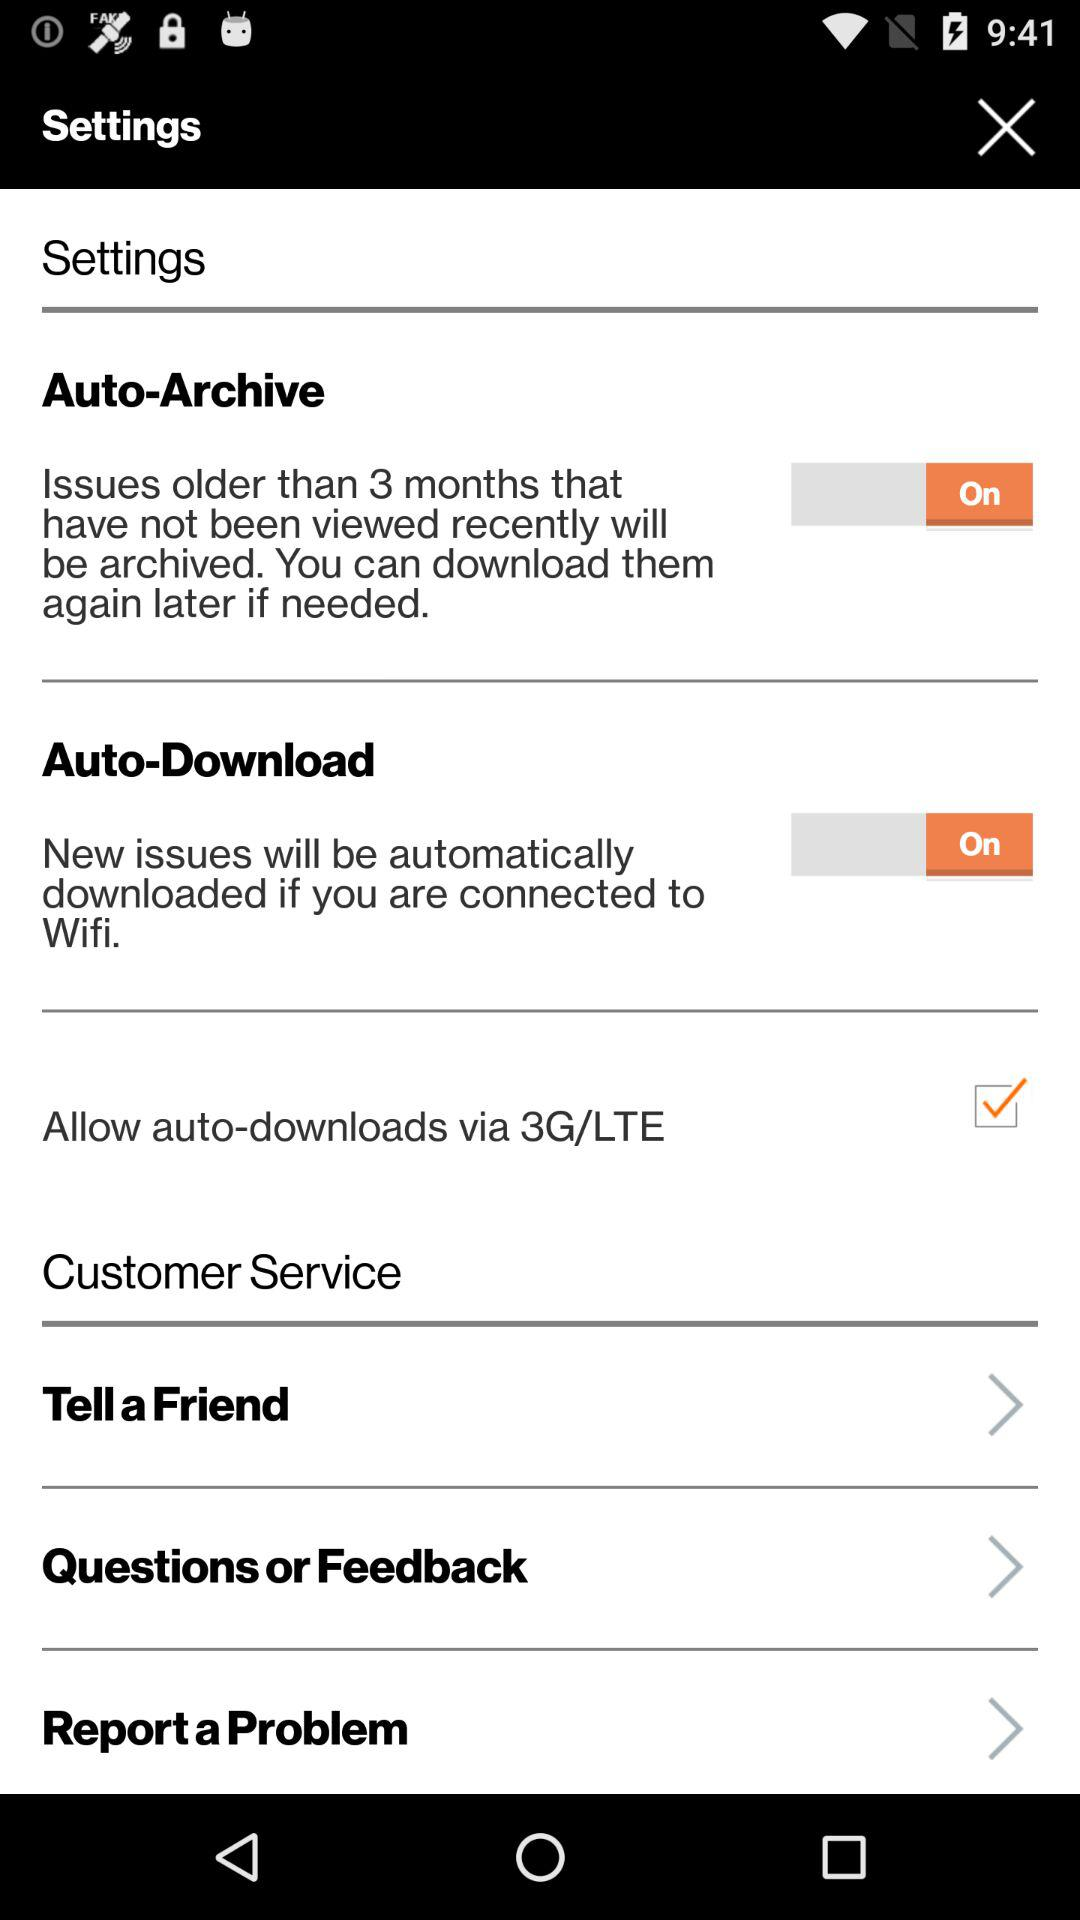What option is checked? The checked option is "Allow auto-downloads via 3G/LTE". 